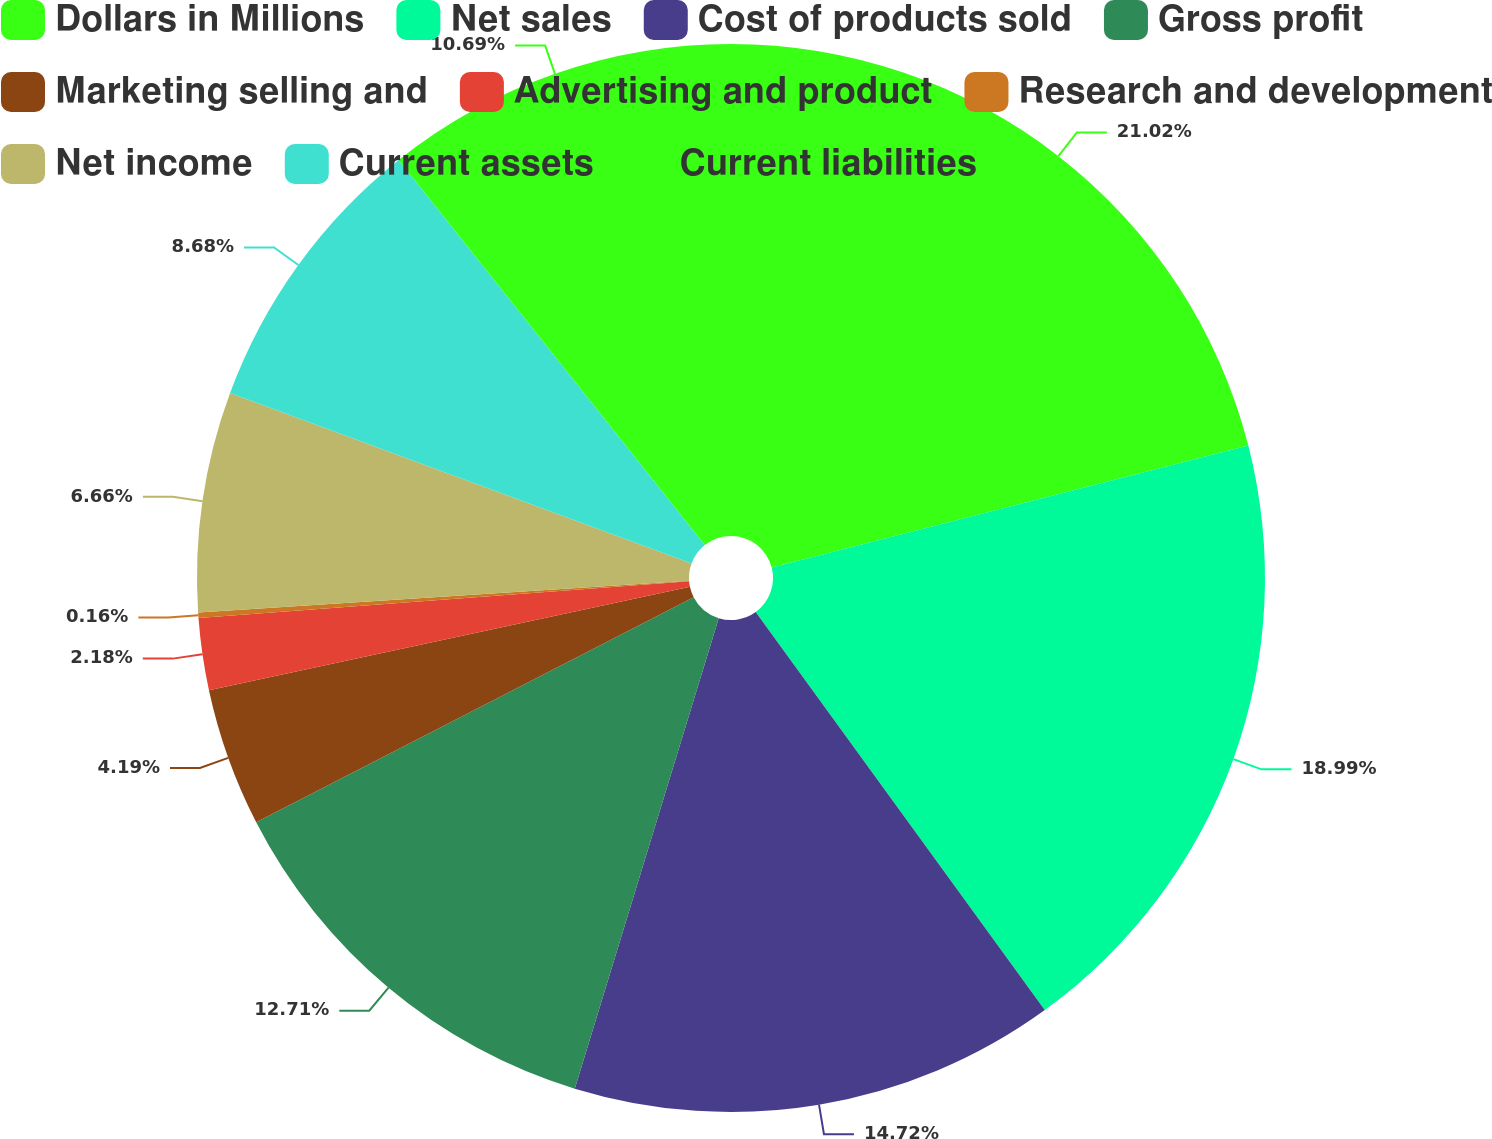Convert chart. <chart><loc_0><loc_0><loc_500><loc_500><pie_chart><fcel>Dollars in Millions<fcel>Net sales<fcel>Cost of products sold<fcel>Gross profit<fcel>Marketing selling and<fcel>Advertising and product<fcel>Research and development<fcel>Net income<fcel>Current assets<fcel>Current liabilities<nl><fcel>21.01%<fcel>18.99%<fcel>14.72%<fcel>12.71%<fcel>4.19%<fcel>2.18%<fcel>0.16%<fcel>6.66%<fcel>8.68%<fcel>10.69%<nl></chart> 